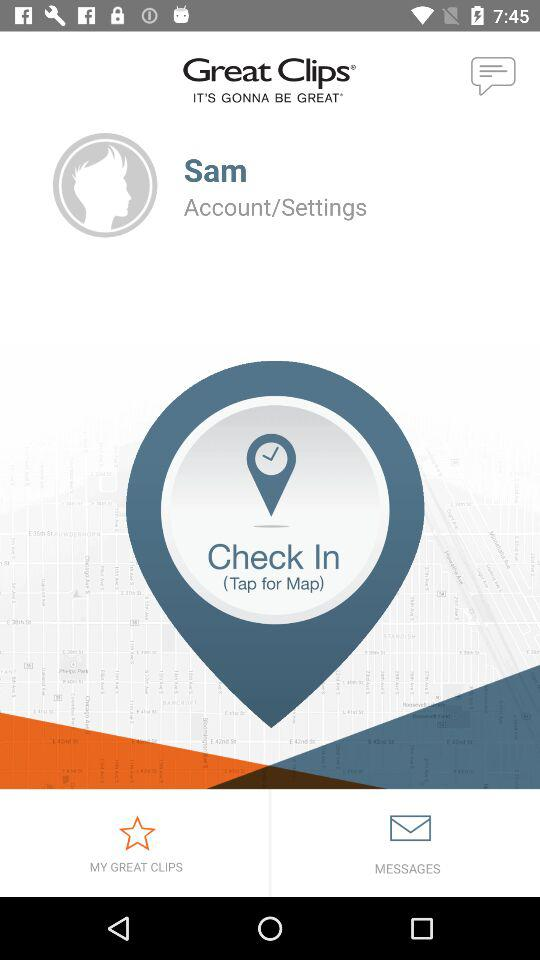What is the name of the user? The name of the user is Sam. 